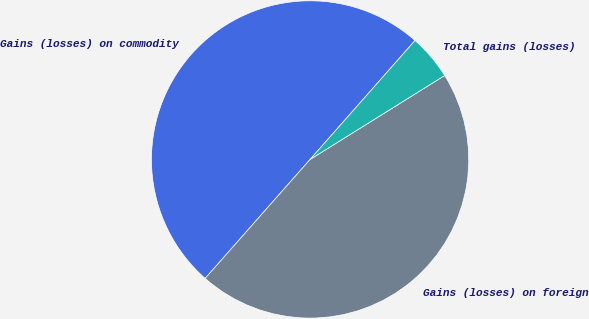Convert chart to OTSL. <chart><loc_0><loc_0><loc_500><loc_500><pie_chart><fcel>Gains (losses) on commodity<fcel>Gains (losses) on foreign<fcel>Total gains (losses)<nl><fcel>50.0%<fcel>45.38%<fcel>4.62%<nl></chart> 